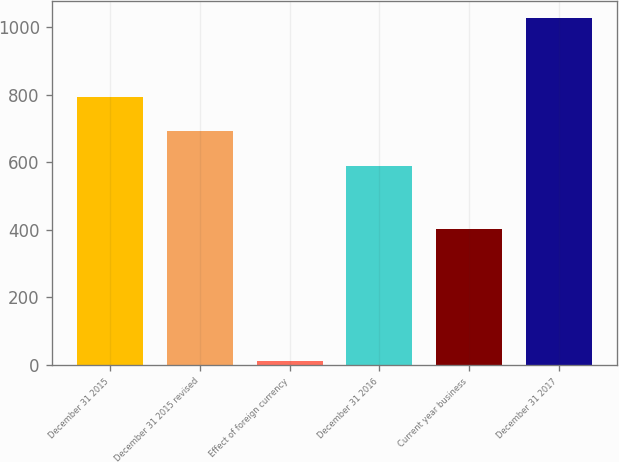Convert chart to OTSL. <chart><loc_0><loc_0><loc_500><loc_500><bar_chart><fcel>December 31 2015<fcel>December 31 2015 revised<fcel>Effect of foreign currency<fcel>December 31 2016<fcel>Current year business<fcel>December 31 2017<nl><fcel>793.74<fcel>692.22<fcel>11.8<fcel>590.7<fcel>403.7<fcel>1027<nl></chart> 